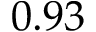<formula> <loc_0><loc_0><loc_500><loc_500>0 . 9 3</formula> 